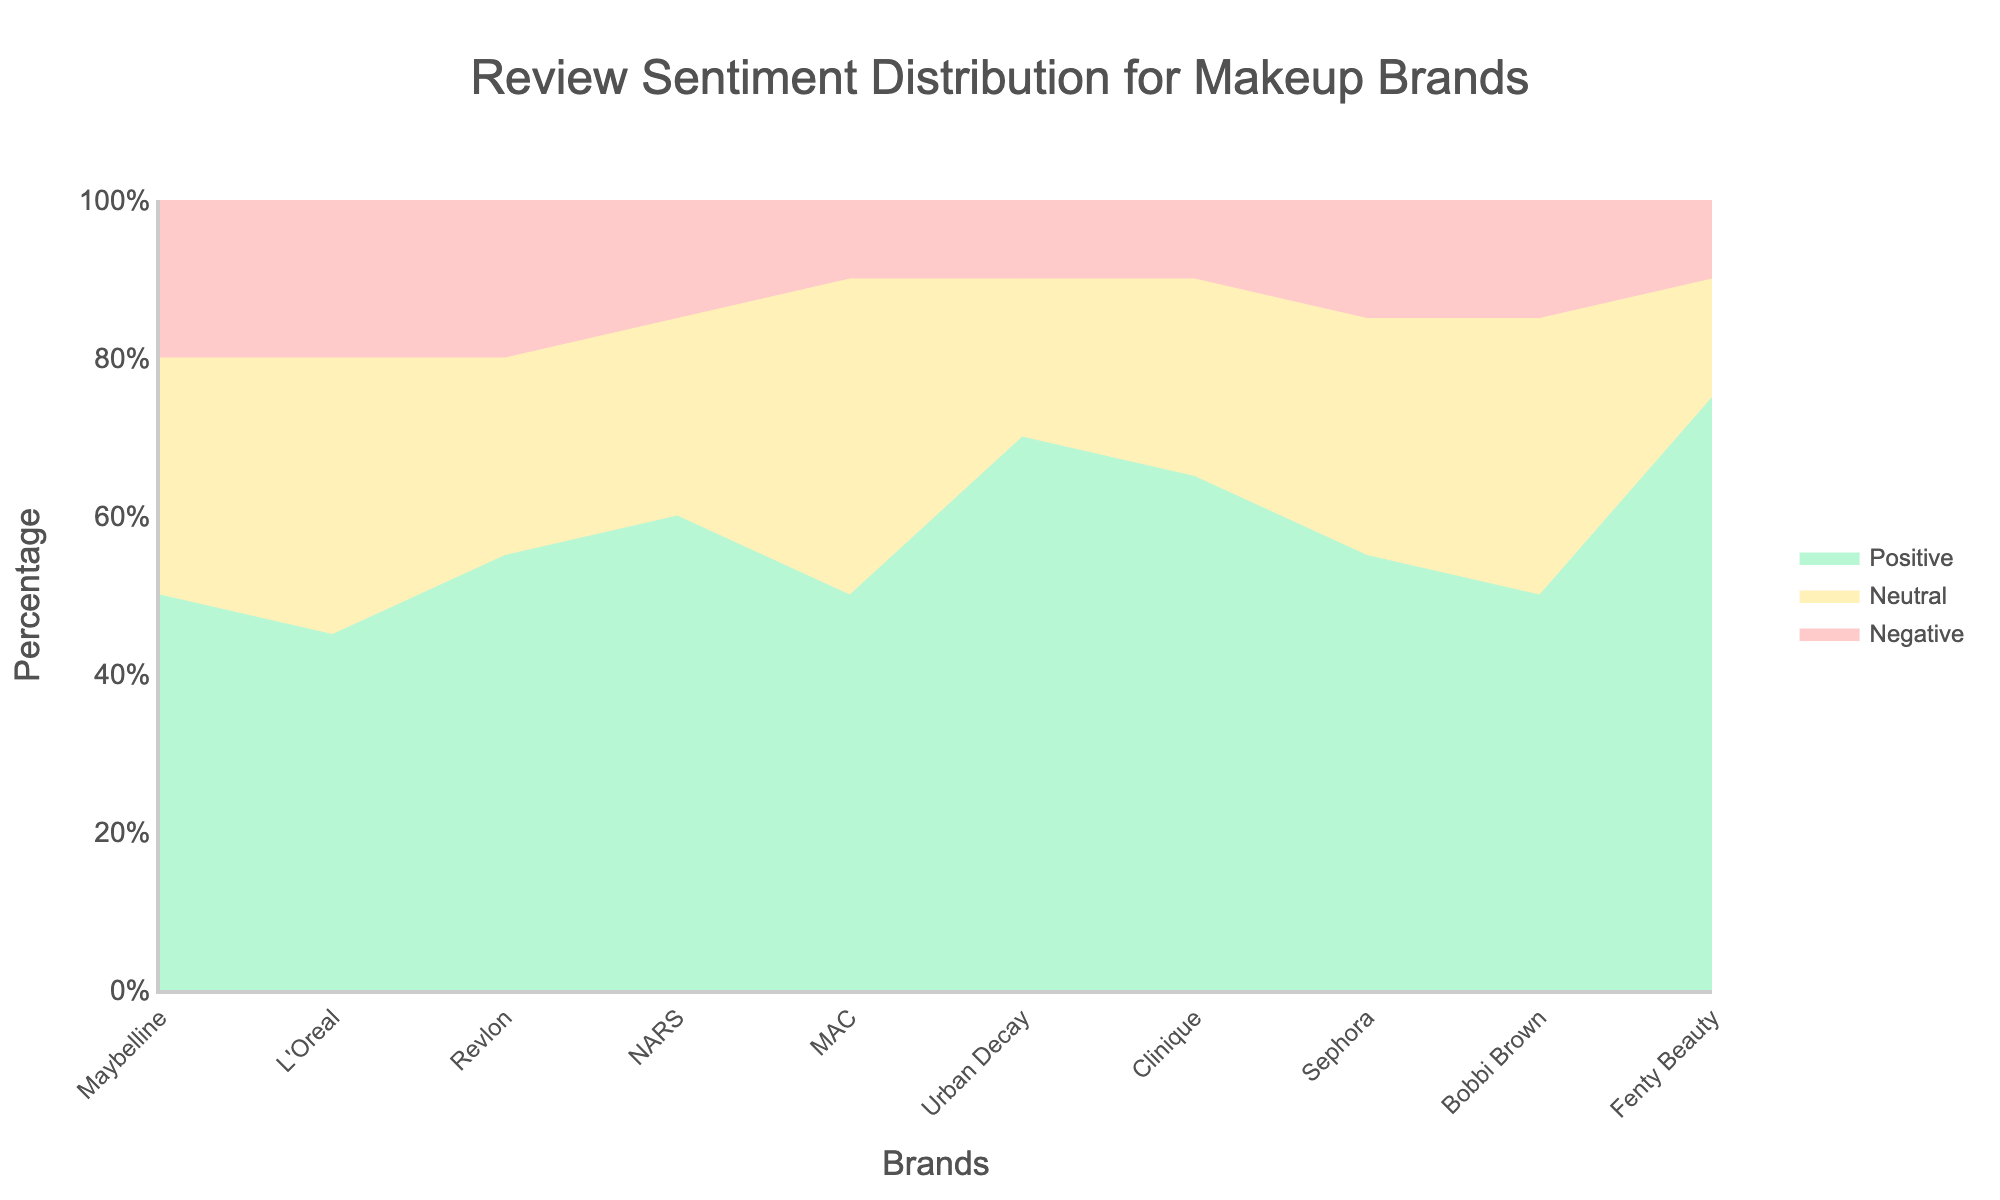Which brand has the highest percentage of positive reviews? Look at the segment representing positive reviews for all brands. The highest point is for Fenty Beauty.
Answer: Fenty Beauty Which brand has the lowest percentage of negative reviews? Examine all the portions representing negative reviews and identify the brand with the smallest segment. This is MAC.
Answer: MAC How does the percentage of neutral reviews for Maybelline compare to Revlon? Identify the segments for neutral reviews for both Maybelline and Revlon. Maybelline has a neutral percentage of 30%, while Revlon has 25%.
Answer: Maybelline has a higher percentage What is the combined percentage of positive and neutral reviews for Urban Decay? Sum up the positive and neutral review percentages for Urban Decay: 70% + 20% = 90%.
Answer: 90% Which two brands have identical percentages of negative reviews? Find the segments with equal lengths for negative reviews. Both Maybelline and L'Oreal have 20% negative reviews.
Answer: Maybelline and L'Oreal How does the sentiment distribution of Sephora compare to Bobbi Brown? For Sephora: Positive 55%, Neutral 30%, Negative 15%. For Bobbi Brown: Positive 50%, Neutral 35%, Negative 15%. Positive is higher for Sephora, neutral is higher for Bobbi Brown, and negative is equal.
Answer: Sephora has higher positive and lower neutral, negatives are equal Which brand has the greatest disparity between its positive and negative review percentages? Calculate the difference between positive and negative percentages for all brands. The highest difference is for Fenty Beauty (75% positive, 10% negative, thus a 65% difference).
Answer: Fenty Beauty How many brands have more than 50% positive reviews? Count the brands with positive percentages higher than 50%. These are Fenty Beauty, Urban Decay, Clinique, NARS, and Revlon.
Answer: 5 brands What is the average percentage of neutral reviews across all brands? Sum the neutral percentages for all brands and divide by the number of brands: (30 + 35 + 25 + 25 + 40 + 20 + 25 + 30 + 35 + 15)/10 = 28%.
Answer: 28% What is the total percentage of negative reviews for MAC and NARS combined? Add the negative percentages of both brands: 10% (MAC) + 15% (NARS) = 25%.
Answer: 25% 